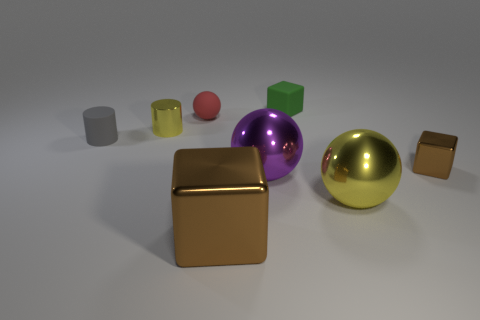Add 2 matte cylinders. How many objects exist? 10 Subtract all spheres. How many objects are left? 5 Add 3 red shiny spheres. How many red shiny spheres exist? 3 Subtract 0 yellow cubes. How many objects are left? 8 Subtract all small things. Subtract all small red objects. How many objects are left? 2 Add 3 small green things. How many small green things are left? 4 